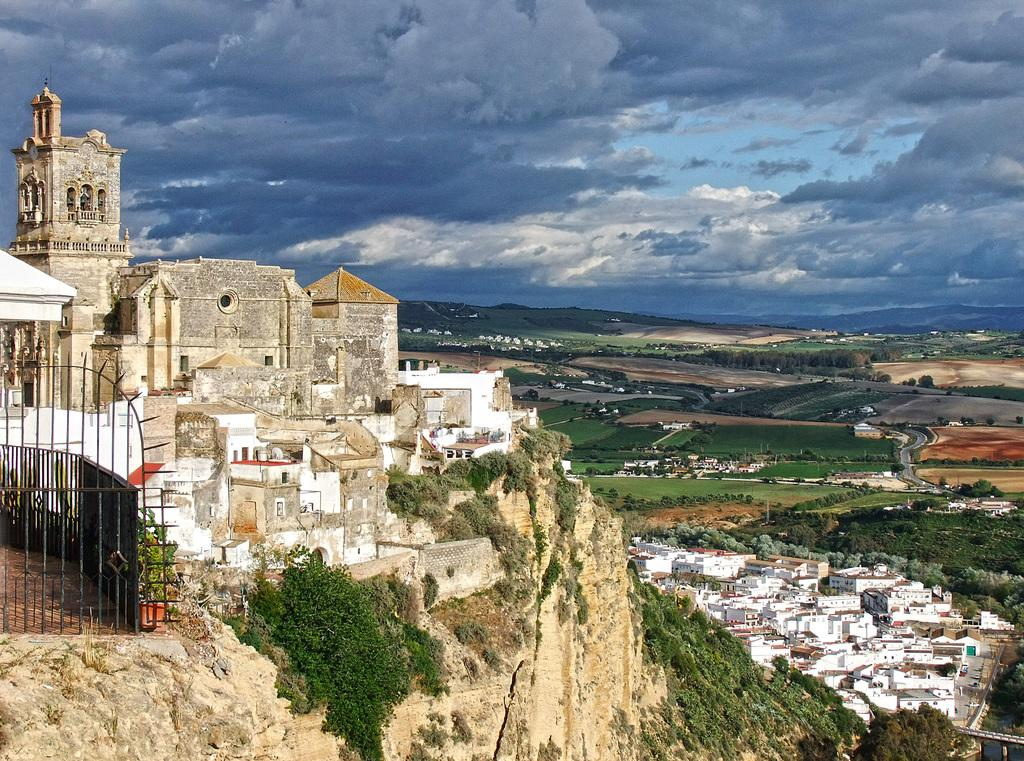What can be seen in the sky in the image? The sky with clouds is visible in the image. What type of structure is present in the image? There is a castle in the image. What other structures can be seen in the image? There are buildings in the image. What architectural feature is present in the image? An iron grill is present in the image. What type of terrain is visible in the image? There is a hill in the image. What type of vegetation is present in the image? Creepers are visible in the image. What is the ground like in the image? The ground is visible in the image. What type of natural environment is present in the image? Trees are present in the image. What type of water feature is visible in the image? Water is visible in the image. What type of spot is visible on the back of the castle in the image? There is no spot visible on the back of the castle in the image, as the image only shows the front of the castle. 